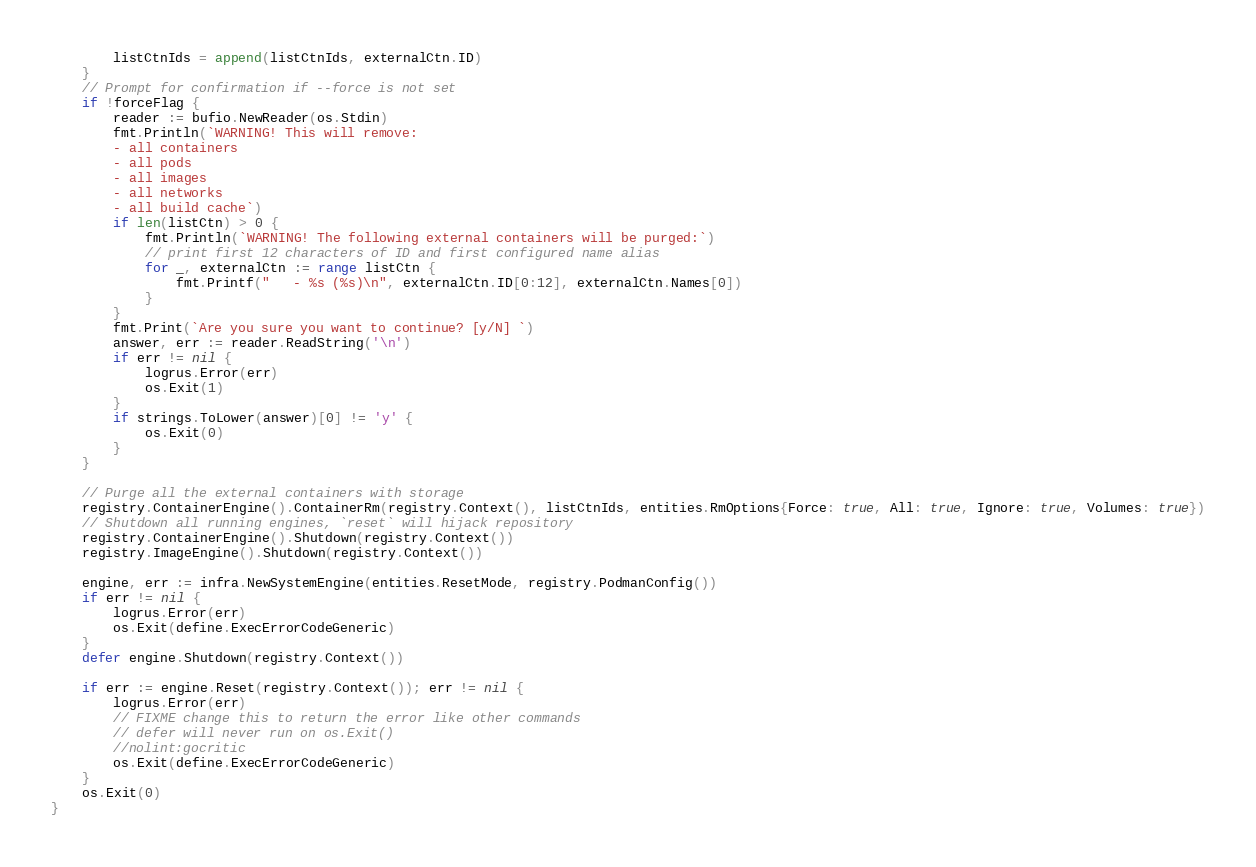<code> <loc_0><loc_0><loc_500><loc_500><_Go_>		listCtnIds = append(listCtnIds, externalCtn.ID)
	}
	// Prompt for confirmation if --force is not set
	if !forceFlag {
		reader := bufio.NewReader(os.Stdin)
		fmt.Println(`WARNING! This will remove:
        - all containers
        - all pods
        - all images
        - all networks
        - all build cache`)
		if len(listCtn) > 0 {
			fmt.Println(`WARNING! The following external containers will be purged:`)
			// print first 12 characters of ID and first configured name alias
			for _, externalCtn := range listCtn {
				fmt.Printf("	- %s (%s)\n", externalCtn.ID[0:12], externalCtn.Names[0])
			}
		}
		fmt.Print(`Are you sure you want to continue? [y/N] `)
		answer, err := reader.ReadString('\n')
		if err != nil {
			logrus.Error(err)
			os.Exit(1)
		}
		if strings.ToLower(answer)[0] != 'y' {
			os.Exit(0)
		}
	}

	// Purge all the external containers with storage
	registry.ContainerEngine().ContainerRm(registry.Context(), listCtnIds, entities.RmOptions{Force: true, All: true, Ignore: true, Volumes: true})
	// Shutdown all running engines, `reset` will hijack repository
	registry.ContainerEngine().Shutdown(registry.Context())
	registry.ImageEngine().Shutdown(registry.Context())

	engine, err := infra.NewSystemEngine(entities.ResetMode, registry.PodmanConfig())
	if err != nil {
		logrus.Error(err)
		os.Exit(define.ExecErrorCodeGeneric)
	}
	defer engine.Shutdown(registry.Context())

	if err := engine.Reset(registry.Context()); err != nil {
		logrus.Error(err)
		// FIXME change this to return the error like other commands
		// defer will never run on os.Exit()
		//nolint:gocritic
		os.Exit(define.ExecErrorCodeGeneric)
	}
	os.Exit(0)
}
</code> 